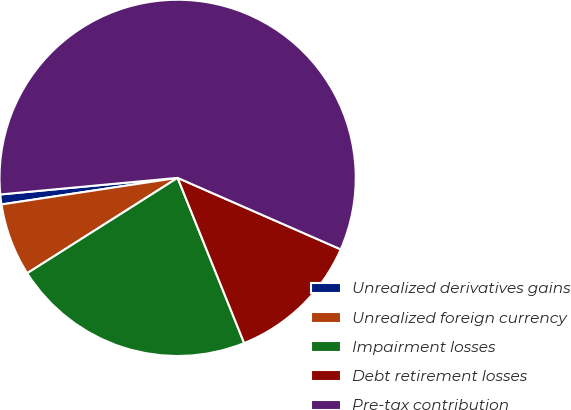<chart> <loc_0><loc_0><loc_500><loc_500><pie_chart><fcel>Unrealized derivatives gains<fcel>Unrealized foreign currency<fcel>Impairment losses<fcel>Debt retirement losses<fcel>Pre-tax contribution<nl><fcel>0.9%<fcel>6.61%<fcel>22.1%<fcel>12.33%<fcel>58.06%<nl></chart> 